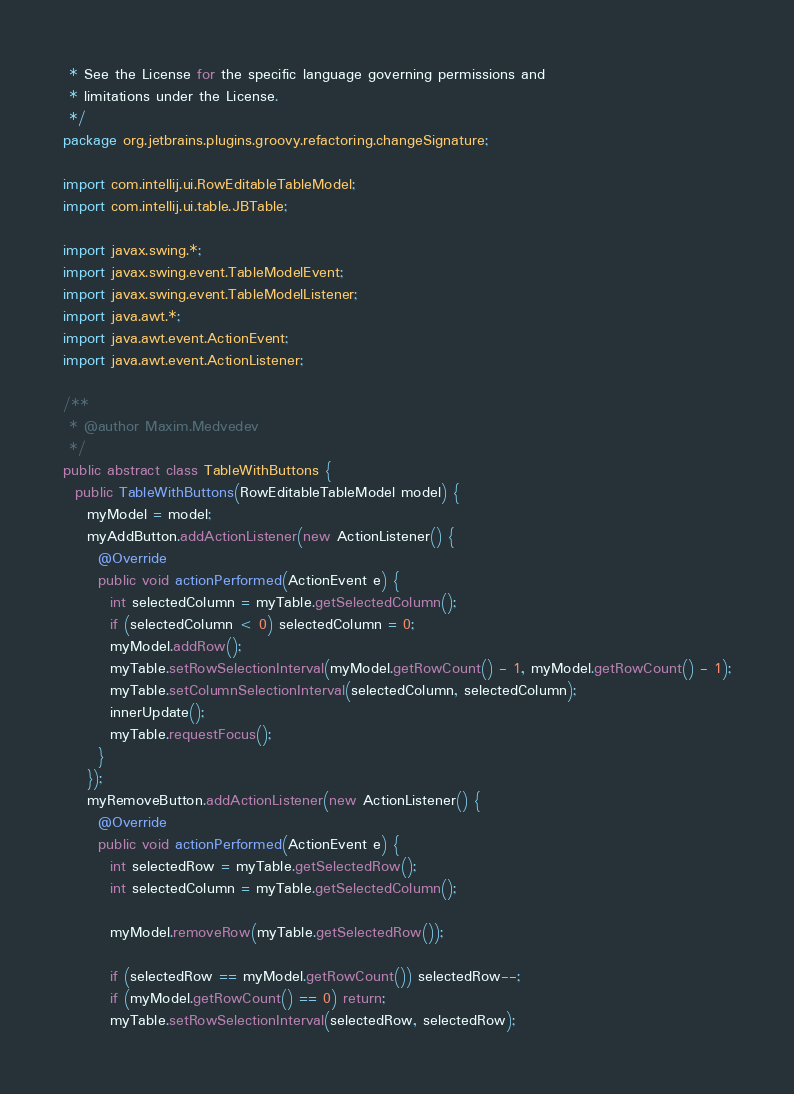Convert code to text. <code><loc_0><loc_0><loc_500><loc_500><_Java_> * See the License for the specific language governing permissions and
 * limitations under the License.
 */
package org.jetbrains.plugins.groovy.refactoring.changeSignature;

import com.intellij.ui.RowEditableTableModel;
import com.intellij.ui.table.JBTable;

import javax.swing.*;
import javax.swing.event.TableModelEvent;
import javax.swing.event.TableModelListener;
import java.awt.*;
import java.awt.event.ActionEvent;
import java.awt.event.ActionListener;

/**
 * @author Maxim.Medvedev
 */
public abstract class TableWithButtons {
  public TableWithButtons(RowEditableTableModel model) {
    myModel = model;
    myAddButton.addActionListener(new ActionListener() {
      @Override
      public void actionPerformed(ActionEvent e) {
        int selectedColumn = myTable.getSelectedColumn();
        if (selectedColumn < 0) selectedColumn = 0;
        myModel.addRow();
        myTable.setRowSelectionInterval(myModel.getRowCount() - 1, myModel.getRowCount() - 1);
        myTable.setColumnSelectionInterval(selectedColumn, selectedColumn);
        innerUpdate();
        myTable.requestFocus();
      }
    });
    myRemoveButton.addActionListener(new ActionListener() {
      @Override
      public void actionPerformed(ActionEvent e) {
        int selectedRow = myTable.getSelectedRow();
        int selectedColumn = myTable.getSelectedColumn();

        myModel.removeRow(myTable.getSelectedRow());

        if (selectedRow == myModel.getRowCount()) selectedRow--;
        if (myModel.getRowCount() == 0) return;
        myTable.setRowSelectionInterval(selectedRow, selectedRow);</code> 